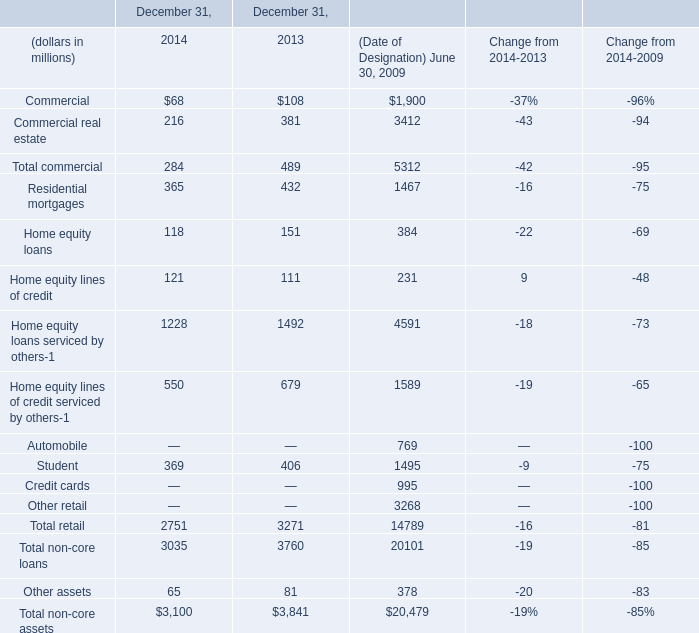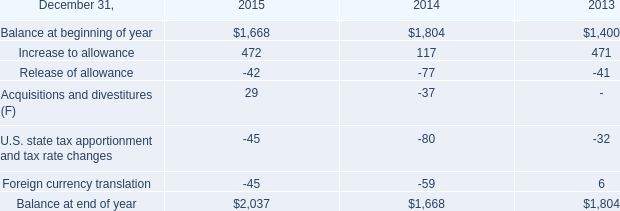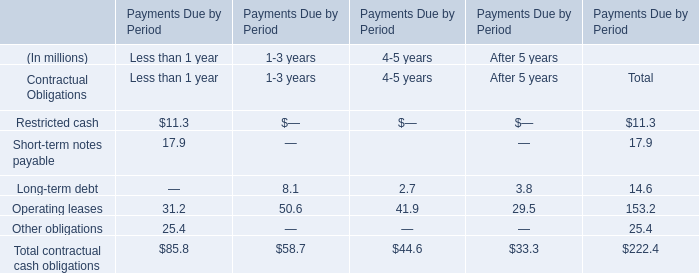considering the additional discrete income tax charge for valuation allowances in 2015 , what is the percentage of the valuation allowance of the deferred tax assets recorded in iceland? 
Computations: (56 / 141)
Answer: 0.39716. 